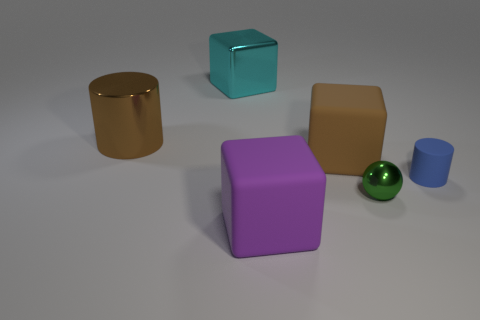There is a small matte cylinder that is right of the big rubber object behind the green thing; are there any tiny green metallic spheres on the left side of it?
Your response must be concise. Yes. How many things are either gray metal cylinders or big metallic things?
Your answer should be very brief. 2. Is the material of the cyan object the same as the big block in front of the blue rubber cylinder?
Offer a very short reply. No. Is there anything else of the same color as the large metallic cube?
Your answer should be compact. No. What number of objects are matte cubes that are behind the blue cylinder or things that are left of the brown block?
Offer a very short reply. 4. What is the shape of the rubber thing that is to the right of the purple thing and to the left of the ball?
Give a very brief answer. Cube. What number of brown metallic cylinders are left of the small object behind the green ball?
Offer a terse response. 1. What number of objects are either metallic cylinders behind the tiny matte object or big cyan metallic blocks?
Your response must be concise. 2. What is the size of the cylinder in front of the big brown metal object?
Your answer should be very brief. Small. What is the material of the big cyan block?
Your answer should be compact. Metal. 